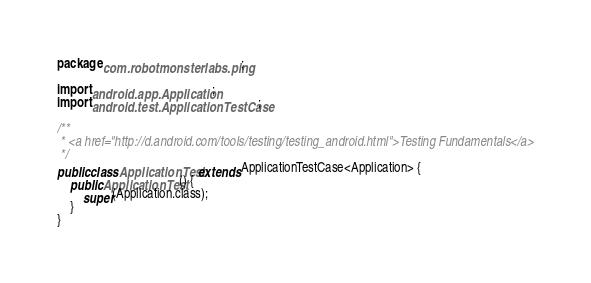Convert code to text. <code><loc_0><loc_0><loc_500><loc_500><_Java_>package com.robotmonsterlabs.ping;

import android.app.Application;
import android.test.ApplicationTestCase;

/**
 * <a href="http://d.android.com/tools/testing/testing_android.html">Testing Fundamentals</a>
 */
public class ApplicationTest extends ApplicationTestCase<Application> {
    public ApplicationTest() {
        super(Application.class);
    }
}</code> 